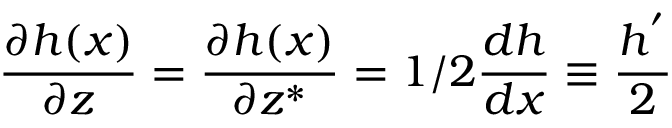Convert formula to latex. <formula><loc_0><loc_0><loc_500><loc_500>\frac { \partial h ( x ) } { \partial z } = \frac { \partial h ( x ) } { \partial z ^ { * } } = 1 / 2 \frac { d h } { d x } \equiv \frac { h ^ { ^ { \prime } } } { 2 }</formula> 